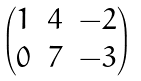<formula> <loc_0><loc_0><loc_500><loc_500>\begin{pmatrix} 1 & 4 & - 2 \\ 0 & 7 & - 3 \end{pmatrix}</formula> 